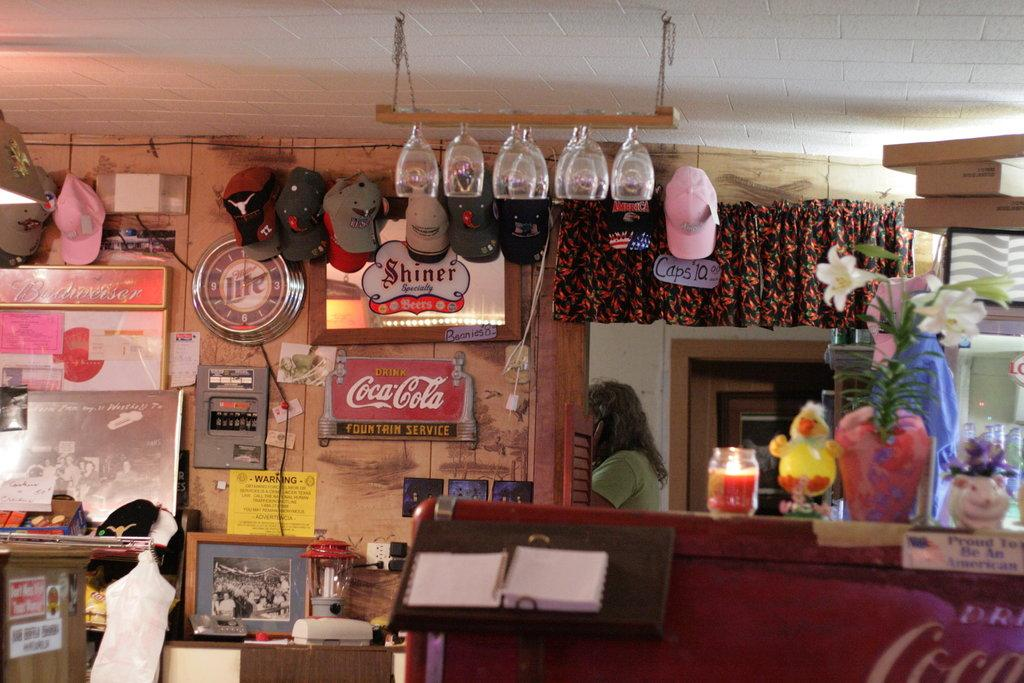<image>
Present a compact description of the photo's key features. A rural style restaurant that has flowers and knickknacks on the counter with Coca-Cola and Shiner Bock beverage signs hang on the wall next to a Miller Lite clock. 